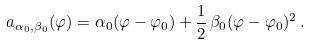<formula> <loc_0><loc_0><loc_500><loc_500>a _ { \alpha _ { 0 } , \beta _ { 0 } } ( \varphi ) = \alpha _ { 0 } ( \varphi - \varphi _ { 0 } ) + \frac { 1 } { 2 } \, \beta _ { 0 } ( \varphi - \varphi _ { 0 } ) ^ { 2 } \, .</formula> 